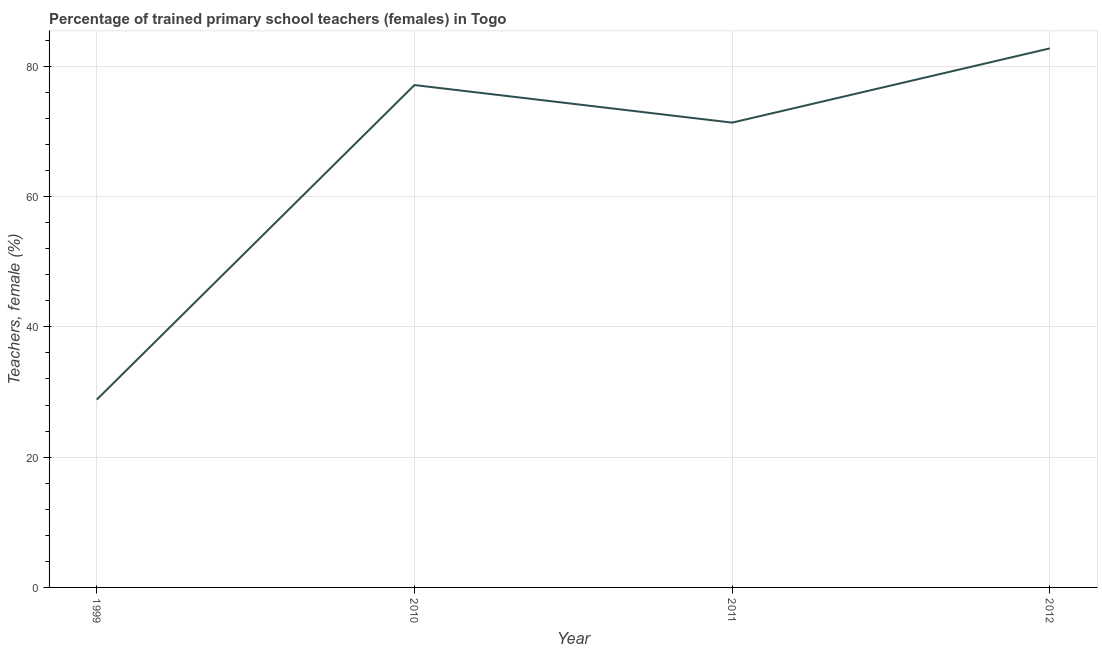What is the percentage of trained female teachers in 2010?
Ensure brevity in your answer.  77.11. Across all years, what is the maximum percentage of trained female teachers?
Keep it short and to the point. 82.74. Across all years, what is the minimum percentage of trained female teachers?
Give a very brief answer. 28.83. What is the sum of the percentage of trained female teachers?
Provide a short and direct response. 260.02. What is the difference between the percentage of trained female teachers in 1999 and 2010?
Your answer should be very brief. -48.28. What is the average percentage of trained female teachers per year?
Your response must be concise. 65. What is the median percentage of trained female teachers?
Offer a very short reply. 74.23. In how many years, is the percentage of trained female teachers greater than 32 %?
Make the answer very short. 3. What is the ratio of the percentage of trained female teachers in 1999 to that in 2012?
Keep it short and to the point. 0.35. Is the difference between the percentage of trained female teachers in 2010 and 2011 greater than the difference between any two years?
Keep it short and to the point. No. What is the difference between the highest and the second highest percentage of trained female teachers?
Make the answer very short. 5.63. What is the difference between the highest and the lowest percentage of trained female teachers?
Provide a succinct answer. 53.91. Does the percentage of trained female teachers monotonically increase over the years?
Your answer should be compact. No. How many years are there in the graph?
Your answer should be very brief. 4. What is the title of the graph?
Your answer should be compact. Percentage of trained primary school teachers (females) in Togo. What is the label or title of the X-axis?
Give a very brief answer. Year. What is the label or title of the Y-axis?
Your answer should be compact. Teachers, female (%). What is the Teachers, female (%) of 1999?
Provide a short and direct response. 28.83. What is the Teachers, female (%) of 2010?
Offer a very short reply. 77.11. What is the Teachers, female (%) in 2011?
Provide a succinct answer. 71.34. What is the Teachers, female (%) of 2012?
Provide a succinct answer. 82.74. What is the difference between the Teachers, female (%) in 1999 and 2010?
Keep it short and to the point. -48.28. What is the difference between the Teachers, female (%) in 1999 and 2011?
Your answer should be very brief. -42.51. What is the difference between the Teachers, female (%) in 1999 and 2012?
Give a very brief answer. -53.91. What is the difference between the Teachers, female (%) in 2010 and 2011?
Provide a short and direct response. 5.77. What is the difference between the Teachers, female (%) in 2010 and 2012?
Make the answer very short. -5.63. What is the difference between the Teachers, female (%) in 2011 and 2012?
Your answer should be very brief. -11.4. What is the ratio of the Teachers, female (%) in 1999 to that in 2010?
Your response must be concise. 0.37. What is the ratio of the Teachers, female (%) in 1999 to that in 2011?
Your response must be concise. 0.4. What is the ratio of the Teachers, female (%) in 1999 to that in 2012?
Make the answer very short. 0.35. What is the ratio of the Teachers, female (%) in 2010 to that in 2011?
Your answer should be compact. 1.08. What is the ratio of the Teachers, female (%) in 2010 to that in 2012?
Ensure brevity in your answer.  0.93. What is the ratio of the Teachers, female (%) in 2011 to that in 2012?
Give a very brief answer. 0.86. 